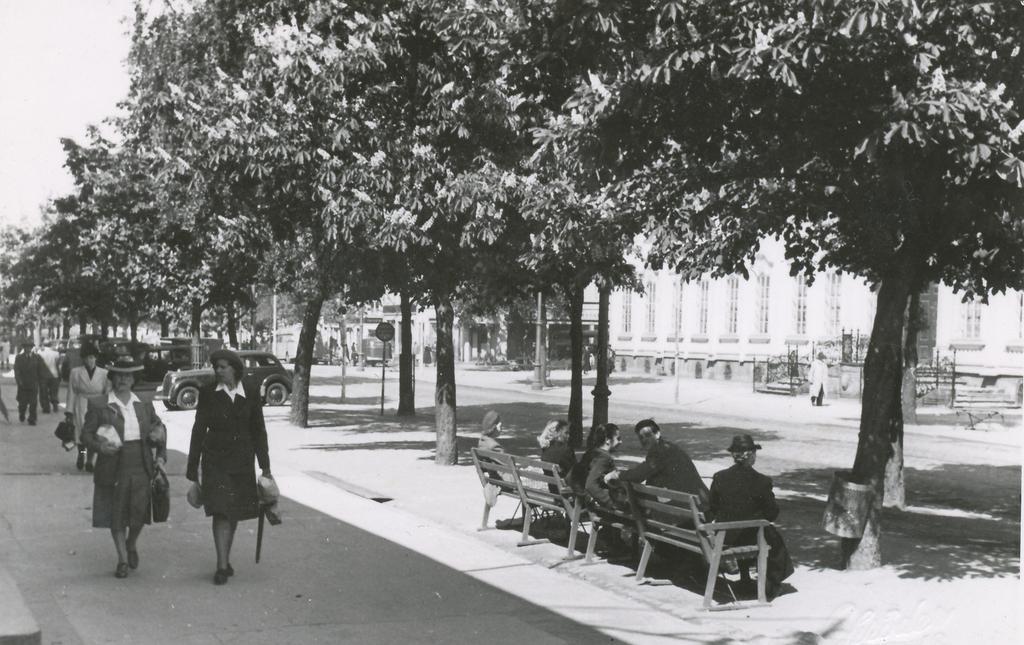How would you summarize this image in a sentence or two? This Picture describe about a old black and white photograph in which a group of men are sitting on the wooden bench facing the faces in the camera screen and two womans wearing black coat and skirt holding the bag and parcel cover in their hands are walking on the road. Behind we can see some more woman walking and many trees and caution boards on the side of the road. Background we can see some building and metal frames are placed in front of their house door. 